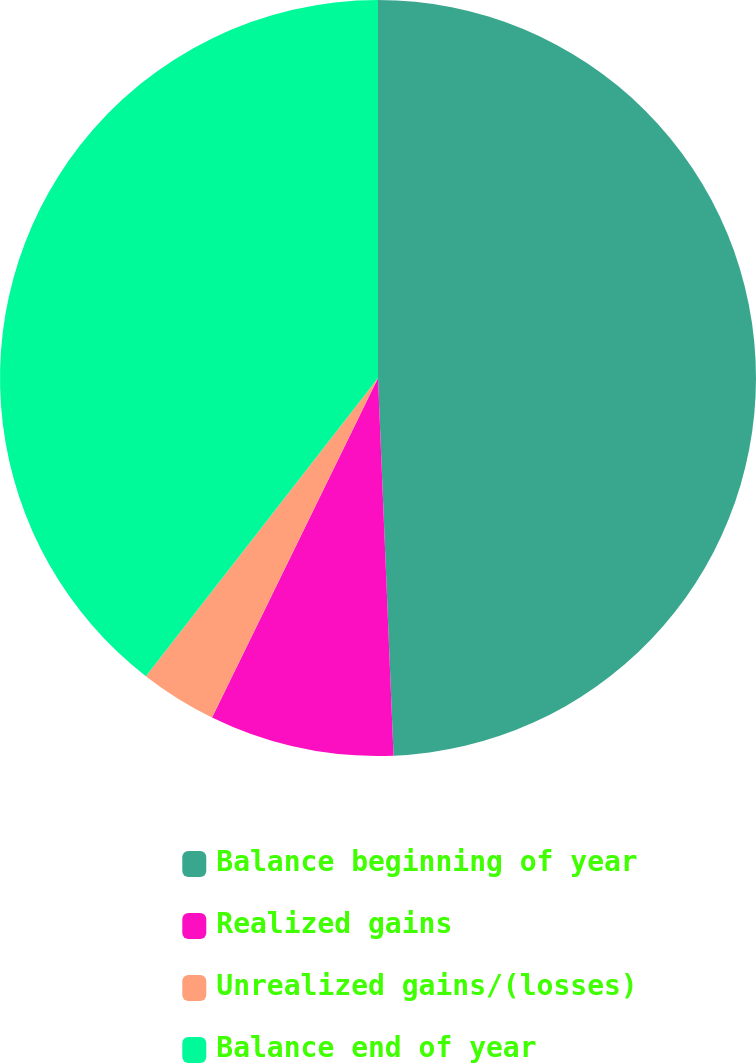Convert chart to OTSL. <chart><loc_0><loc_0><loc_500><loc_500><pie_chart><fcel>Balance beginning of year<fcel>Realized gains<fcel>Unrealized gains/(losses)<fcel>Balance end of year<nl><fcel>49.34%<fcel>7.89%<fcel>3.29%<fcel>39.47%<nl></chart> 